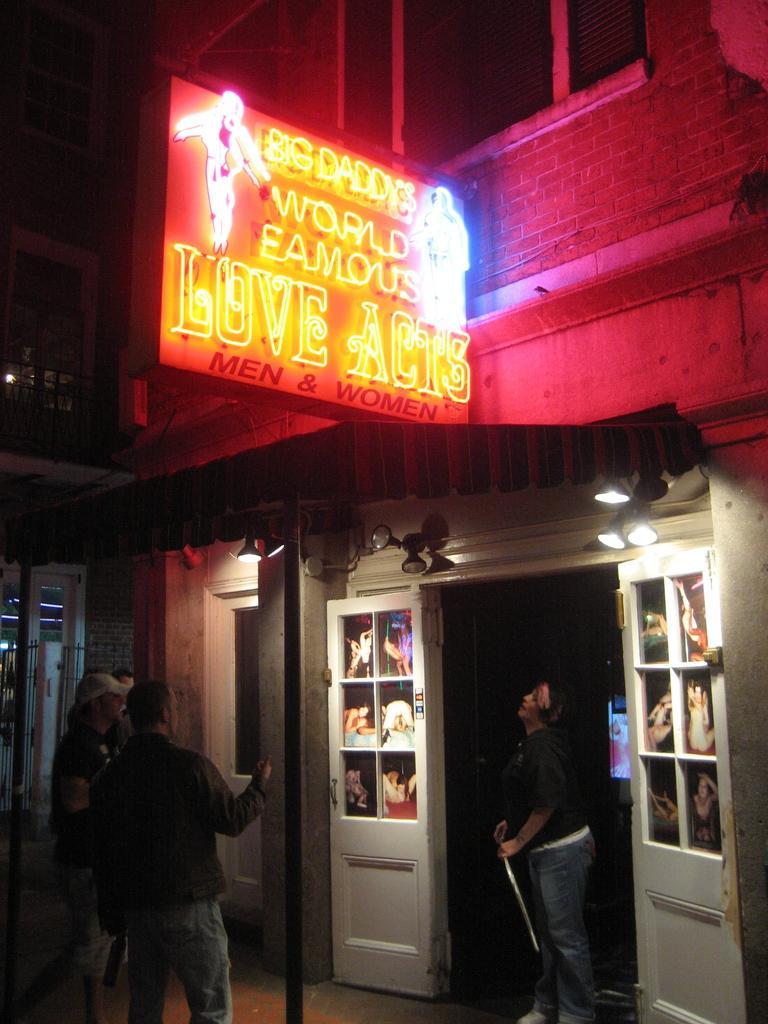Please provide a concise description of this image. Here in this picture we can see a building present over there and we can see some people standing on the ground in front of the building and we can see doors of it and we can see lights at the top of it and in the middle we can see a hoarding with different colored lights present over there and we can also see windows present over there. 